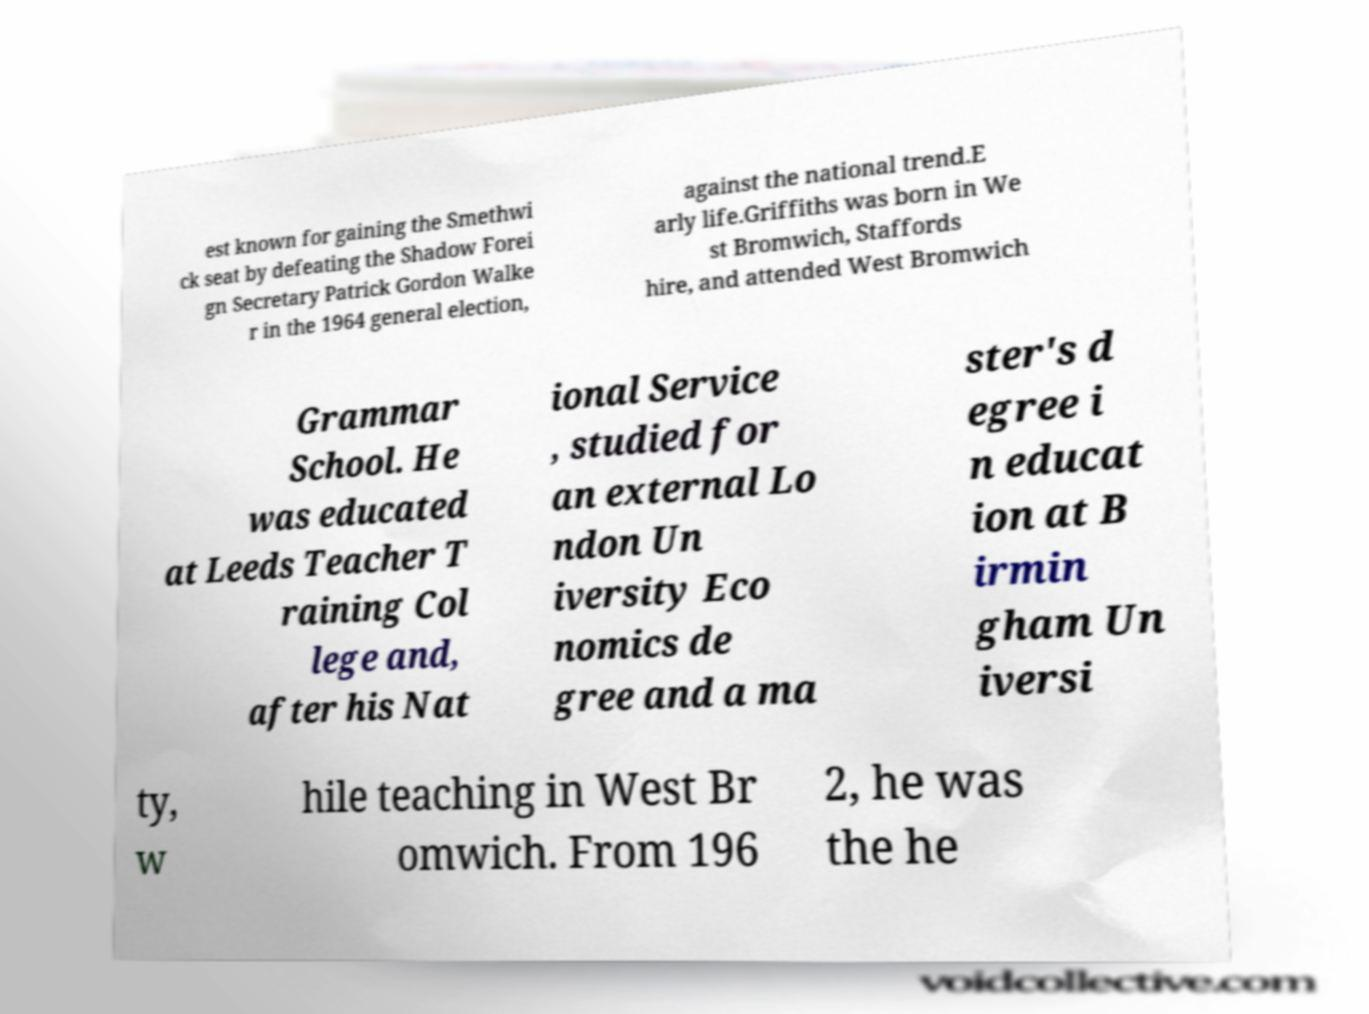Please read and relay the text visible in this image. What does it say? est known for gaining the Smethwi ck seat by defeating the Shadow Forei gn Secretary Patrick Gordon Walke r in the 1964 general election, against the national trend.E arly life.Griffiths was born in We st Bromwich, Staffords hire, and attended West Bromwich Grammar School. He was educated at Leeds Teacher T raining Col lege and, after his Nat ional Service , studied for an external Lo ndon Un iversity Eco nomics de gree and a ma ster's d egree i n educat ion at B irmin gham Un iversi ty, w hile teaching in West Br omwich. From 196 2, he was the he 